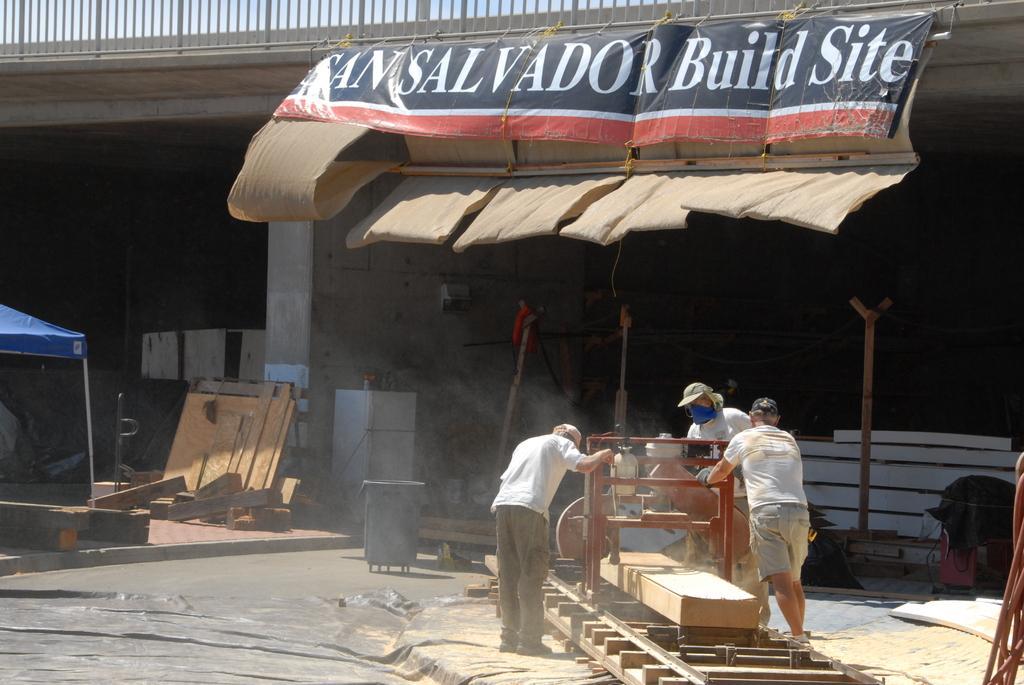How would you summarize this image in a sentence or two? In this picture we can see group of people, in front of them we can see a machine, in the background we can find a hoarding, tent, wooden barks and a refrigerator, and also we can see a building. 